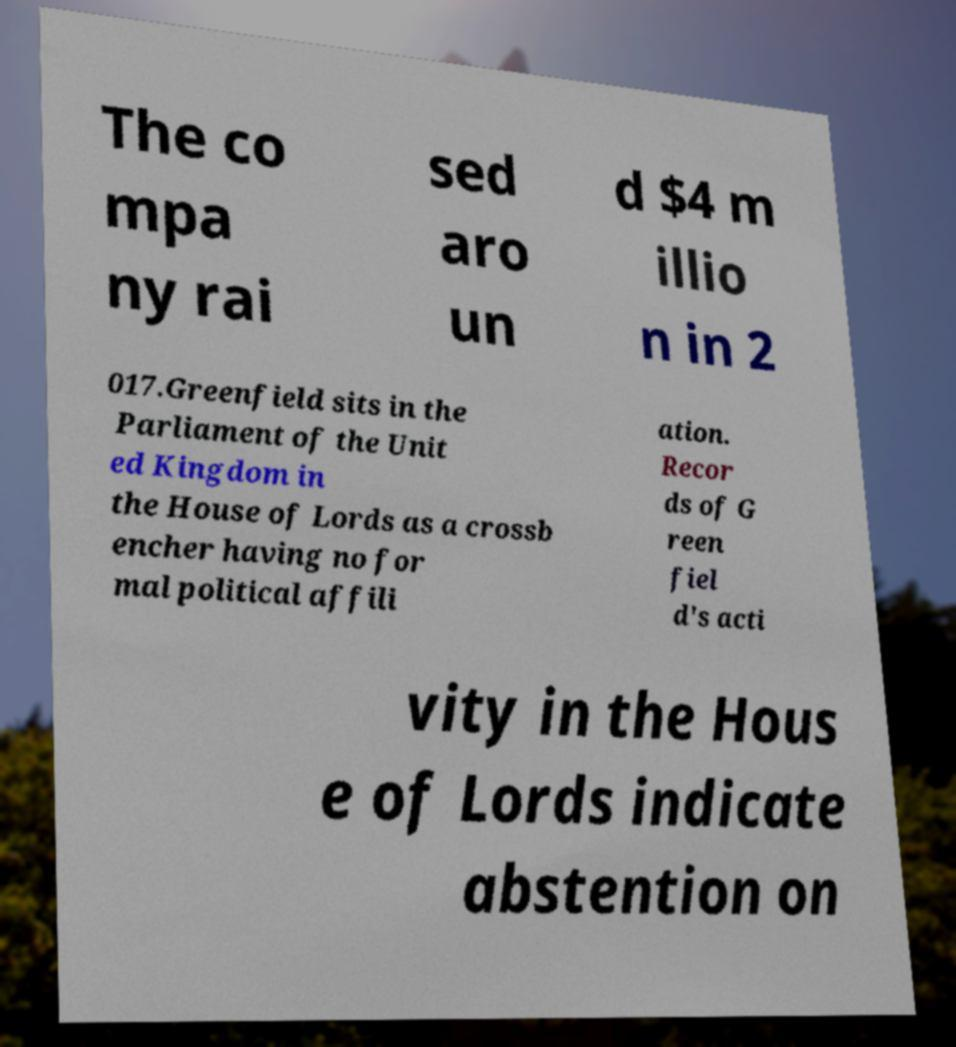Could you assist in decoding the text presented in this image and type it out clearly? The co mpa ny rai sed aro un d $4 m illio n in 2 017.Greenfield sits in the Parliament of the Unit ed Kingdom in the House of Lords as a crossb encher having no for mal political affili ation. Recor ds of G reen fiel d's acti vity in the Hous e of Lords indicate abstention on 